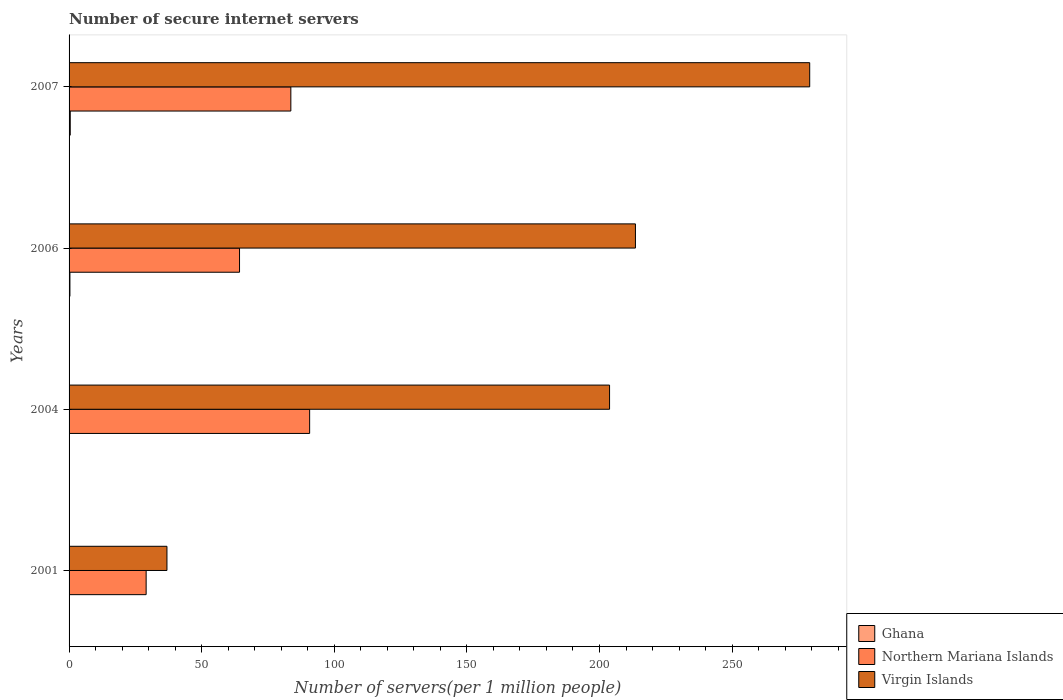How many different coloured bars are there?
Offer a terse response. 3. What is the label of the 1st group of bars from the top?
Your response must be concise. 2007. What is the number of secure internet servers in Northern Mariana Islands in 2007?
Your answer should be compact. 83.62. Across all years, what is the maximum number of secure internet servers in Northern Mariana Islands?
Your answer should be very brief. 90.71. Across all years, what is the minimum number of secure internet servers in Northern Mariana Islands?
Your answer should be very brief. 29.06. In which year was the number of secure internet servers in Ghana minimum?
Provide a short and direct response. 2004. What is the total number of secure internet servers in Northern Mariana Islands in the graph?
Give a very brief answer. 267.67. What is the difference between the number of secure internet servers in Ghana in 2006 and that in 2007?
Your response must be concise. -0.13. What is the difference between the number of secure internet servers in Northern Mariana Islands in 2004 and the number of secure internet servers in Virgin Islands in 2006?
Keep it short and to the point. -122.84. What is the average number of secure internet servers in Northern Mariana Islands per year?
Make the answer very short. 66.92. In the year 2004, what is the difference between the number of secure internet servers in Northern Mariana Islands and number of secure internet servers in Ghana?
Your answer should be very brief. 90.66. In how many years, is the number of secure internet servers in Virgin Islands greater than 250 ?
Your answer should be very brief. 1. What is the ratio of the number of secure internet servers in Northern Mariana Islands in 2006 to that in 2007?
Keep it short and to the point. 0.77. Is the number of secure internet servers in Ghana in 2004 less than that in 2006?
Provide a short and direct response. Yes. Is the difference between the number of secure internet servers in Northern Mariana Islands in 2001 and 2004 greater than the difference between the number of secure internet servers in Ghana in 2001 and 2004?
Your response must be concise. No. What is the difference between the highest and the second highest number of secure internet servers in Virgin Islands?
Your response must be concise. 65.71. What is the difference between the highest and the lowest number of secure internet servers in Virgin Islands?
Ensure brevity in your answer.  242.36. In how many years, is the number of secure internet servers in Northern Mariana Islands greater than the average number of secure internet servers in Northern Mariana Islands taken over all years?
Offer a very short reply. 2. Is the sum of the number of secure internet servers in Ghana in 2004 and 2007 greater than the maximum number of secure internet servers in Northern Mariana Islands across all years?
Your response must be concise. No. What does the 3rd bar from the top in 2001 represents?
Your response must be concise. Ghana. What does the 3rd bar from the bottom in 2001 represents?
Keep it short and to the point. Virgin Islands. Are all the bars in the graph horizontal?
Ensure brevity in your answer.  Yes. Are the values on the major ticks of X-axis written in scientific E-notation?
Keep it short and to the point. No. How many legend labels are there?
Offer a very short reply. 3. How are the legend labels stacked?
Provide a succinct answer. Vertical. What is the title of the graph?
Ensure brevity in your answer.  Number of secure internet servers. Does "East Asia (developing only)" appear as one of the legend labels in the graph?
Your answer should be very brief. No. What is the label or title of the X-axis?
Offer a very short reply. Number of servers(per 1 million people). What is the label or title of the Y-axis?
Provide a succinct answer. Years. What is the Number of servers(per 1 million people) in Ghana in 2001?
Keep it short and to the point. 0.05. What is the Number of servers(per 1 million people) of Northern Mariana Islands in 2001?
Your response must be concise. 29.06. What is the Number of servers(per 1 million people) in Virgin Islands in 2001?
Provide a succinct answer. 36.91. What is the Number of servers(per 1 million people) in Ghana in 2004?
Your answer should be very brief. 0.05. What is the Number of servers(per 1 million people) in Northern Mariana Islands in 2004?
Ensure brevity in your answer.  90.71. What is the Number of servers(per 1 million people) in Virgin Islands in 2004?
Provide a short and direct response. 203.8. What is the Number of servers(per 1 million people) in Ghana in 2006?
Keep it short and to the point. 0.32. What is the Number of servers(per 1 million people) in Northern Mariana Islands in 2006?
Your response must be concise. 64.27. What is the Number of servers(per 1 million people) in Virgin Islands in 2006?
Your answer should be very brief. 213.56. What is the Number of servers(per 1 million people) of Ghana in 2007?
Offer a very short reply. 0.44. What is the Number of servers(per 1 million people) of Northern Mariana Islands in 2007?
Your response must be concise. 83.62. What is the Number of servers(per 1 million people) of Virgin Islands in 2007?
Provide a short and direct response. 279.27. Across all years, what is the maximum Number of servers(per 1 million people) in Ghana?
Your answer should be compact. 0.44. Across all years, what is the maximum Number of servers(per 1 million people) in Northern Mariana Islands?
Offer a very short reply. 90.71. Across all years, what is the maximum Number of servers(per 1 million people) of Virgin Islands?
Offer a very short reply. 279.27. Across all years, what is the minimum Number of servers(per 1 million people) in Ghana?
Give a very brief answer. 0.05. Across all years, what is the minimum Number of servers(per 1 million people) of Northern Mariana Islands?
Provide a short and direct response. 29.06. Across all years, what is the minimum Number of servers(per 1 million people) in Virgin Islands?
Your answer should be compact. 36.91. What is the total Number of servers(per 1 million people) in Ghana in the graph?
Your response must be concise. 0.86. What is the total Number of servers(per 1 million people) of Northern Mariana Islands in the graph?
Offer a terse response. 267.67. What is the total Number of servers(per 1 million people) of Virgin Islands in the graph?
Your answer should be compact. 733.53. What is the difference between the Number of servers(per 1 million people) of Ghana in 2001 and that in 2004?
Provide a succinct answer. 0. What is the difference between the Number of servers(per 1 million people) of Northern Mariana Islands in 2001 and that in 2004?
Your answer should be very brief. -61.65. What is the difference between the Number of servers(per 1 million people) in Virgin Islands in 2001 and that in 2004?
Offer a terse response. -166.89. What is the difference between the Number of servers(per 1 million people) of Ghana in 2001 and that in 2006?
Provide a succinct answer. -0.27. What is the difference between the Number of servers(per 1 million people) of Northern Mariana Islands in 2001 and that in 2006?
Your answer should be compact. -35.21. What is the difference between the Number of servers(per 1 million people) in Virgin Islands in 2001 and that in 2006?
Provide a succinct answer. -176.65. What is the difference between the Number of servers(per 1 million people) in Ghana in 2001 and that in 2007?
Make the answer very short. -0.39. What is the difference between the Number of servers(per 1 million people) in Northern Mariana Islands in 2001 and that in 2007?
Your response must be concise. -54.56. What is the difference between the Number of servers(per 1 million people) in Virgin Islands in 2001 and that in 2007?
Your response must be concise. -242.36. What is the difference between the Number of servers(per 1 million people) of Ghana in 2004 and that in 2006?
Offer a very short reply. -0.27. What is the difference between the Number of servers(per 1 million people) of Northern Mariana Islands in 2004 and that in 2006?
Ensure brevity in your answer.  26.44. What is the difference between the Number of servers(per 1 million people) in Virgin Islands in 2004 and that in 2006?
Offer a terse response. -9.76. What is the difference between the Number of servers(per 1 million people) in Ghana in 2004 and that in 2007?
Offer a terse response. -0.4. What is the difference between the Number of servers(per 1 million people) of Northern Mariana Islands in 2004 and that in 2007?
Keep it short and to the point. 7.09. What is the difference between the Number of servers(per 1 million people) in Virgin Islands in 2004 and that in 2007?
Offer a very short reply. -75.47. What is the difference between the Number of servers(per 1 million people) in Ghana in 2006 and that in 2007?
Offer a terse response. -0.12. What is the difference between the Number of servers(per 1 million people) in Northern Mariana Islands in 2006 and that in 2007?
Keep it short and to the point. -19.35. What is the difference between the Number of servers(per 1 million people) in Virgin Islands in 2006 and that in 2007?
Your answer should be very brief. -65.71. What is the difference between the Number of servers(per 1 million people) in Ghana in 2001 and the Number of servers(per 1 million people) in Northern Mariana Islands in 2004?
Your answer should be very brief. -90.66. What is the difference between the Number of servers(per 1 million people) of Ghana in 2001 and the Number of servers(per 1 million people) of Virgin Islands in 2004?
Ensure brevity in your answer.  -203.75. What is the difference between the Number of servers(per 1 million people) of Northern Mariana Islands in 2001 and the Number of servers(per 1 million people) of Virgin Islands in 2004?
Keep it short and to the point. -174.74. What is the difference between the Number of servers(per 1 million people) in Ghana in 2001 and the Number of servers(per 1 million people) in Northern Mariana Islands in 2006?
Provide a succinct answer. -64.22. What is the difference between the Number of servers(per 1 million people) in Ghana in 2001 and the Number of servers(per 1 million people) in Virgin Islands in 2006?
Provide a succinct answer. -213.5. What is the difference between the Number of servers(per 1 million people) in Northern Mariana Islands in 2001 and the Number of servers(per 1 million people) in Virgin Islands in 2006?
Your response must be concise. -184.49. What is the difference between the Number of servers(per 1 million people) in Ghana in 2001 and the Number of servers(per 1 million people) in Northern Mariana Islands in 2007?
Make the answer very short. -83.57. What is the difference between the Number of servers(per 1 million people) in Ghana in 2001 and the Number of servers(per 1 million people) in Virgin Islands in 2007?
Keep it short and to the point. -279.22. What is the difference between the Number of servers(per 1 million people) in Northern Mariana Islands in 2001 and the Number of servers(per 1 million people) in Virgin Islands in 2007?
Your answer should be very brief. -250.21. What is the difference between the Number of servers(per 1 million people) of Ghana in 2004 and the Number of servers(per 1 million people) of Northern Mariana Islands in 2006?
Give a very brief answer. -64.22. What is the difference between the Number of servers(per 1 million people) of Ghana in 2004 and the Number of servers(per 1 million people) of Virgin Islands in 2006?
Give a very brief answer. -213.51. What is the difference between the Number of servers(per 1 million people) of Northern Mariana Islands in 2004 and the Number of servers(per 1 million people) of Virgin Islands in 2006?
Keep it short and to the point. -122.84. What is the difference between the Number of servers(per 1 million people) of Ghana in 2004 and the Number of servers(per 1 million people) of Northern Mariana Islands in 2007?
Provide a short and direct response. -83.58. What is the difference between the Number of servers(per 1 million people) of Ghana in 2004 and the Number of servers(per 1 million people) of Virgin Islands in 2007?
Your answer should be very brief. -279.22. What is the difference between the Number of servers(per 1 million people) in Northern Mariana Islands in 2004 and the Number of servers(per 1 million people) in Virgin Islands in 2007?
Provide a short and direct response. -188.56. What is the difference between the Number of servers(per 1 million people) in Ghana in 2006 and the Number of servers(per 1 million people) in Northern Mariana Islands in 2007?
Your answer should be very brief. -83.31. What is the difference between the Number of servers(per 1 million people) in Ghana in 2006 and the Number of servers(per 1 million people) in Virgin Islands in 2007?
Your response must be concise. -278.95. What is the difference between the Number of servers(per 1 million people) in Northern Mariana Islands in 2006 and the Number of servers(per 1 million people) in Virgin Islands in 2007?
Make the answer very short. -215. What is the average Number of servers(per 1 million people) of Ghana per year?
Keep it short and to the point. 0.22. What is the average Number of servers(per 1 million people) of Northern Mariana Islands per year?
Offer a terse response. 66.92. What is the average Number of servers(per 1 million people) of Virgin Islands per year?
Your answer should be compact. 183.38. In the year 2001, what is the difference between the Number of servers(per 1 million people) in Ghana and Number of servers(per 1 million people) in Northern Mariana Islands?
Provide a short and direct response. -29.01. In the year 2001, what is the difference between the Number of servers(per 1 million people) of Ghana and Number of servers(per 1 million people) of Virgin Islands?
Your answer should be compact. -36.85. In the year 2001, what is the difference between the Number of servers(per 1 million people) of Northern Mariana Islands and Number of servers(per 1 million people) of Virgin Islands?
Provide a succinct answer. -7.84. In the year 2004, what is the difference between the Number of servers(per 1 million people) of Ghana and Number of servers(per 1 million people) of Northern Mariana Islands?
Make the answer very short. -90.66. In the year 2004, what is the difference between the Number of servers(per 1 million people) of Ghana and Number of servers(per 1 million people) of Virgin Islands?
Offer a very short reply. -203.75. In the year 2004, what is the difference between the Number of servers(per 1 million people) of Northern Mariana Islands and Number of servers(per 1 million people) of Virgin Islands?
Give a very brief answer. -113.09. In the year 2006, what is the difference between the Number of servers(per 1 million people) of Ghana and Number of servers(per 1 million people) of Northern Mariana Islands?
Provide a succinct answer. -63.95. In the year 2006, what is the difference between the Number of servers(per 1 million people) in Ghana and Number of servers(per 1 million people) in Virgin Islands?
Offer a very short reply. -213.24. In the year 2006, what is the difference between the Number of servers(per 1 million people) in Northern Mariana Islands and Number of servers(per 1 million people) in Virgin Islands?
Make the answer very short. -149.28. In the year 2007, what is the difference between the Number of servers(per 1 million people) in Ghana and Number of servers(per 1 million people) in Northern Mariana Islands?
Your answer should be compact. -83.18. In the year 2007, what is the difference between the Number of servers(per 1 million people) of Ghana and Number of servers(per 1 million people) of Virgin Islands?
Provide a succinct answer. -278.83. In the year 2007, what is the difference between the Number of servers(per 1 million people) of Northern Mariana Islands and Number of servers(per 1 million people) of Virgin Islands?
Offer a very short reply. -195.65. What is the ratio of the Number of servers(per 1 million people) of Ghana in 2001 to that in 2004?
Provide a succinct answer. 1.08. What is the ratio of the Number of servers(per 1 million people) of Northern Mariana Islands in 2001 to that in 2004?
Make the answer very short. 0.32. What is the ratio of the Number of servers(per 1 million people) of Virgin Islands in 2001 to that in 2004?
Offer a terse response. 0.18. What is the ratio of the Number of servers(per 1 million people) of Ghana in 2001 to that in 2006?
Your answer should be very brief. 0.16. What is the ratio of the Number of servers(per 1 million people) of Northern Mariana Islands in 2001 to that in 2006?
Offer a very short reply. 0.45. What is the ratio of the Number of servers(per 1 million people) of Virgin Islands in 2001 to that in 2006?
Make the answer very short. 0.17. What is the ratio of the Number of servers(per 1 million people) in Ghana in 2001 to that in 2007?
Provide a succinct answer. 0.12. What is the ratio of the Number of servers(per 1 million people) of Northern Mariana Islands in 2001 to that in 2007?
Offer a terse response. 0.35. What is the ratio of the Number of servers(per 1 million people) of Virgin Islands in 2001 to that in 2007?
Your answer should be compact. 0.13. What is the ratio of the Number of servers(per 1 million people) in Ghana in 2004 to that in 2006?
Provide a succinct answer. 0.15. What is the ratio of the Number of servers(per 1 million people) of Northern Mariana Islands in 2004 to that in 2006?
Your response must be concise. 1.41. What is the ratio of the Number of servers(per 1 million people) of Virgin Islands in 2004 to that in 2006?
Provide a short and direct response. 0.95. What is the ratio of the Number of servers(per 1 million people) of Ghana in 2004 to that in 2007?
Make the answer very short. 0.11. What is the ratio of the Number of servers(per 1 million people) of Northern Mariana Islands in 2004 to that in 2007?
Give a very brief answer. 1.08. What is the ratio of the Number of servers(per 1 million people) in Virgin Islands in 2004 to that in 2007?
Offer a very short reply. 0.73. What is the ratio of the Number of servers(per 1 million people) of Ghana in 2006 to that in 2007?
Make the answer very short. 0.72. What is the ratio of the Number of servers(per 1 million people) of Northern Mariana Islands in 2006 to that in 2007?
Ensure brevity in your answer.  0.77. What is the ratio of the Number of servers(per 1 million people) in Virgin Islands in 2006 to that in 2007?
Your answer should be very brief. 0.76. What is the difference between the highest and the second highest Number of servers(per 1 million people) of Ghana?
Offer a very short reply. 0.12. What is the difference between the highest and the second highest Number of servers(per 1 million people) in Northern Mariana Islands?
Your answer should be very brief. 7.09. What is the difference between the highest and the second highest Number of servers(per 1 million people) of Virgin Islands?
Ensure brevity in your answer.  65.71. What is the difference between the highest and the lowest Number of servers(per 1 million people) in Ghana?
Offer a very short reply. 0.4. What is the difference between the highest and the lowest Number of servers(per 1 million people) in Northern Mariana Islands?
Ensure brevity in your answer.  61.65. What is the difference between the highest and the lowest Number of servers(per 1 million people) in Virgin Islands?
Provide a short and direct response. 242.36. 